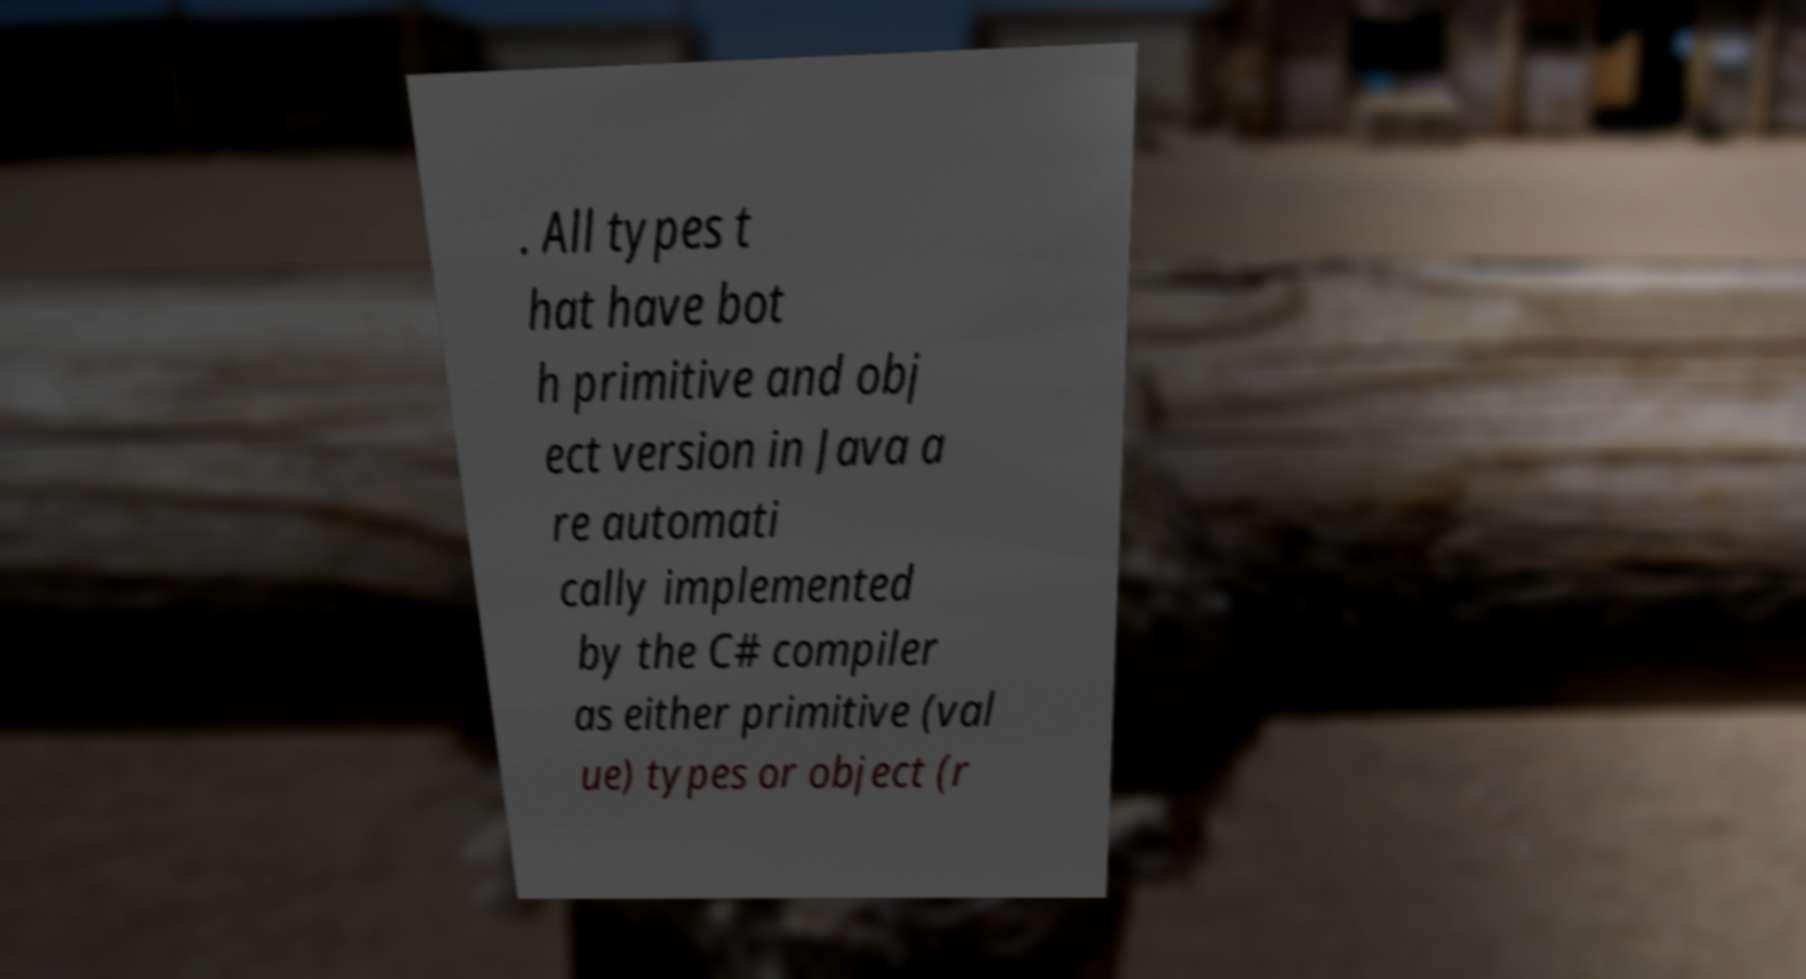There's text embedded in this image that I need extracted. Can you transcribe it verbatim? . All types t hat have bot h primitive and obj ect version in Java a re automati cally implemented by the C# compiler as either primitive (val ue) types or object (r 